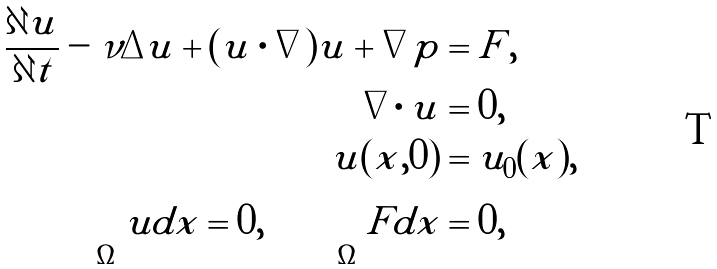Convert formula to latex. <formula><loc_0><loc_0><loc_500><loc_500>\frac { \partial u } { \partial t } - \nu \Delta u + ( u \cdot \nabla ) u + \nabla p & = F , \\ \nabla \cdot u & = 0 , \\ u ( x , 0 ) & = u _ { 0 } ( x ) , \\ \int _ { \Omega } u d x = 0 , \quad \int _ { \Omega } F d x & = 0 ,</formula> 